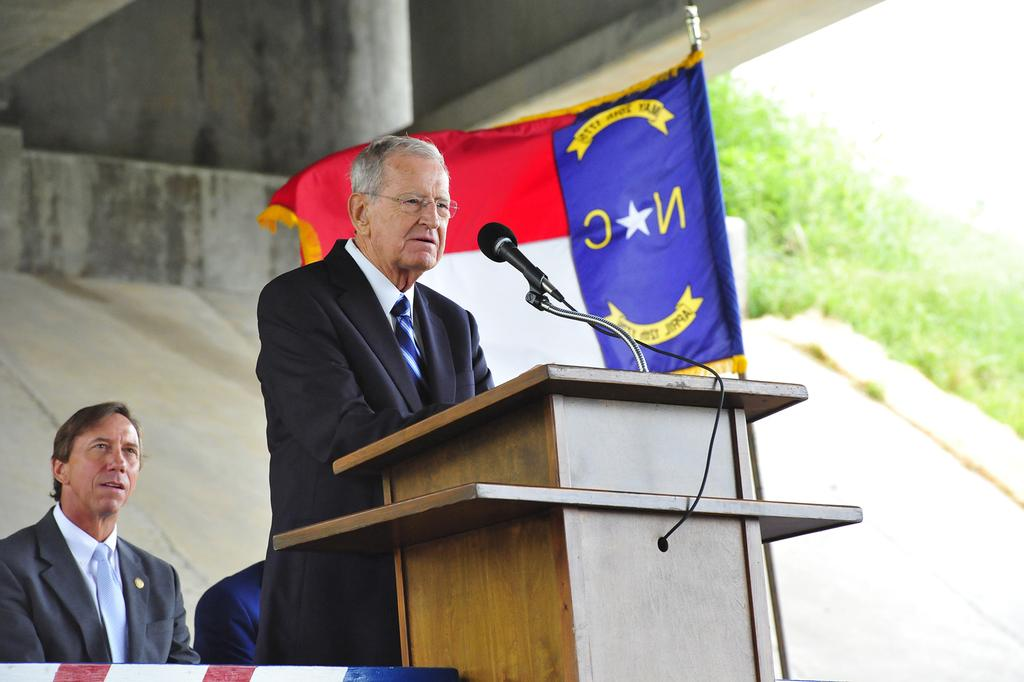What is the main subject of the image? The main subject of the image is a guy. What is the guy doing in the image? The guy is standing in front of a mic and talking. What can be seen in the background of the image? There is a flag in the background of the image. What flavor of ice cream is the guy eating in the image? There is no ice cream present in the image, and the guy is not eating anything. 